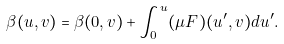Convert formula to latex. <formula><loc_0><loc_0><loc_500><loc_500>\beta ( u , v ) = \beta ( 0 , v ) + \int _ { 0 } ^ { u } ( \mu F ) ( u ^ { \prime } , v ) d u ^ { \prime } .</formula> 